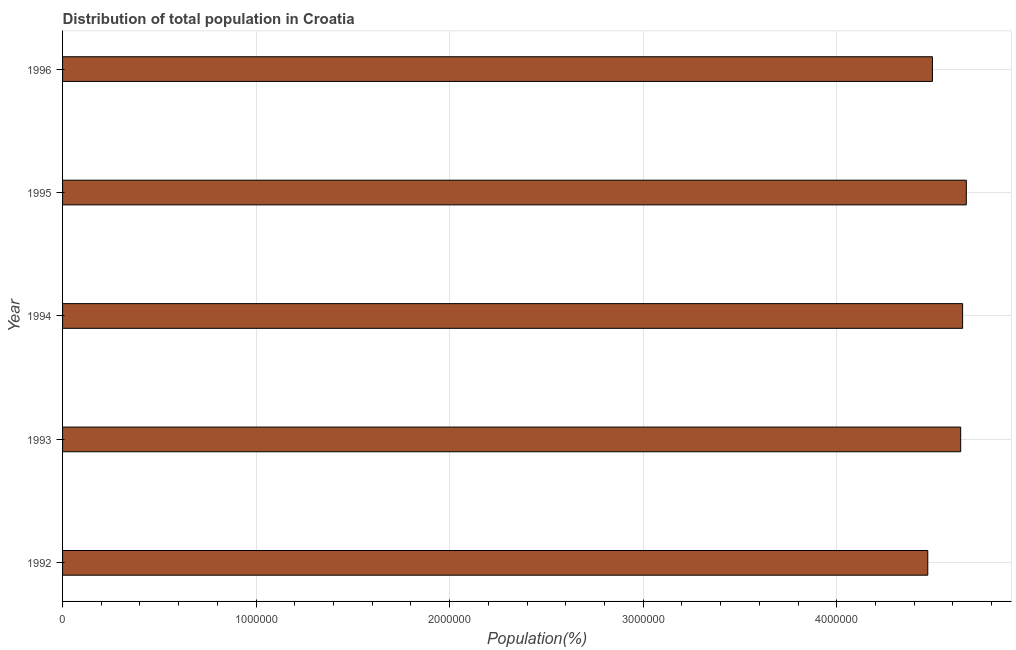Does the graph contain grids?
Your answer should be compact. Yes. What is the title of the graph?
Offer a very short reply. Distribution of total population in Croatia . What is the label or title of the X-axis?
Your response must be concise. Population(%). What is the population in 1992?
Make the answer very short. 4.47e+06. Across all years, what is the maximum population?
Your answer should be compact. 4.67e+06. Across all years, what is the minimum population?
Ensure brevity in your answer.  4.47e+06. What is the sum of the population?
Provide a short and direct response. 2.29e+07. What is the difference between the population in 1995 and 1996?
Offer a very short reply. 1.75e+05. What is the average population per year?
Your answer should be compact. 4.58e+06. What is the median population?
Offer a very short reply. 4.64e+06. Do a majority of the years between 1993 and 1992 (inclusive) have population greater than 400000 %?
Give a very brief answer. No. What is the ratio of the population in 1995 to that in 1996?
Keep it short and to the point. 1.04. Is the difference between the population in 1992 and 1996 greater than the difference between any two years?
Your response must be concise. No. What is the difference between the highest and the second highest population?
Give a very brief answer. 1.90e+04. What is the difference between the highest and the lowest population?
Provide a short and direct response. 1.99e+05. In how many years, is the population greater than the average population taken over all years?
Provide a short and direct response. 3. Are all the bars in the graph horizontal?
Provide a succinct answer. Yes. Are the values on the major ticks of X-axis written in scientific E-notation?
Your response must be concise. No. What is the Population(%) of 1992?
Your answer should be compact. 4.47e+06. What is the Population(%) in 1993?
Ensure brevity in your answer.  4.64e+06. What is the Population(%) of 1994?
Ensure brevity in your answer.  4.65e+06. What is the Population(%) of 1995?
Give a very brief answer. 4.67e+06. What is the Population(%) of 1996?
Make the answer very short. 4.49e+06. What is the difference between the Population(%) in 1992 and 1995?
Your answer should be compact. -1.99e+05. What is the difference between the Population(%) in 1992 and 1996?
Your answer should be very brief. -2.40e+04. What is the difference between the Population(%) in 1993 and 1995?
Provide a short and direct response. -2.90e+04. What is the difference between the Population(%) in 1993 and 1996?
Offer a very short reply. 1.46e+05. What is the difference between the Population(%) in 1994 and 1995?
Keep it short and to the point. -1.90e+04. What is the difference between the Population(%) in 1994 and 1996?
Give a very brief answer. 1.56e+05. What is the difference between the Population(%) in 1995 and 1996?
Give a very brief answer. 1.75e+05. What is the ratio of the Population(%) in 1992 to that in 1993?
Make the answer very short. 0.96. What is the ratio of the Population(%) in 1993 to that in 1994?
Ensure brevity in your answer.  1. What is the ratio of the Population(%) in 1993 to that in 1995?
Make the answer very short. 0.99. What is the ratio of the Population(%) in 1993 to that in 1996?
Ensure brevity in your answer.  1.03. What is the ratio of the Population(%) in 1994 to that in 1995?
Give a very brief answer. 1. What is the ratio of the Population(%) in 1994 to that in 1996?
Provide a succinct answer. 1.03. What is the ratio of the Population(%) in 1995 to that in 1996?
Provide a succinct answer. 1.04. 